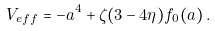Convert formula to latex. <formula><loc_0><loc_0><loc_500><loc_500>V _ { e f f } = - a ^ { 4 } + \zeta ( 3 - 4 \eta ) f _ { 0 } ( a ) \, .</formula> 